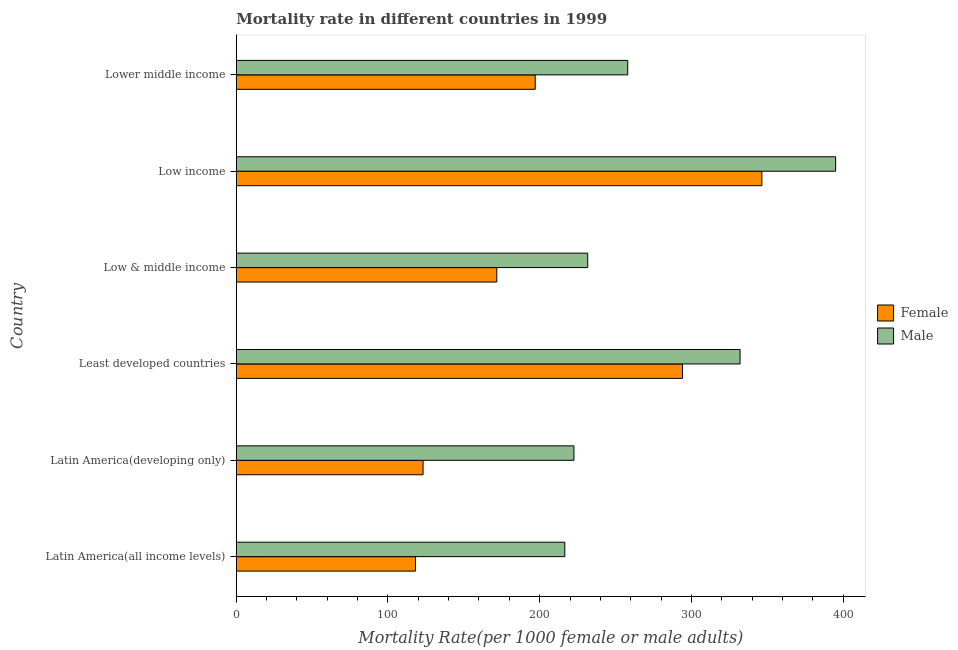How many different coloured bars are there?
Your answer should be compact. 2. Are the number of bars per tick equal to the number of legend labels?
Offer a terse response. Yes. Are the number of bars on each tick of the Y-axis equal?
Offer a terse response. Yes. How many bars are there on the 4th tick from the top?
Keep it short and to the point. 2. How many bars are there on the 6th tick from the bottom?
Your answer should be very brief. 2. What is the label of the 6th group of bars from the top?
Your response must be concise. Latin America(all income levels). In how many cases, is the number of bars for a given country not equal to the number of legend labels?
Make the answer very short. 0. What is the male mortality rate in Lower middle income?
Your response must be concise. 258.05. Across all countries, what is the maximum female mortality rate?
Keep it short and to the point. 346.49. Across all countries, what is the minimum male mortality rate?
Ensure brevity in your answer.  216.57. In which country was the male mortality rate maximum?
Offer a very short reply. Low income. In which country was the female mortality rate minimum?
Ensure brevity in your answer.  Latin America(all income levels). What is the total male mortality rate in the graph?
Offer a terse response. 1656.06. What is the difference between the male mortality rate in Latin America(all income levels) and that in Low & middle income?
Give a very brief answer. -15.1. What is the difference between the female mortality rate in Lower middle income and the male mortality rate in Latin America(all income levels)?
Give a very brief answer. -19.48. What is the average male mortality rate per country?
Provide a short and direct response. 276.01. What is the difference between the male mortality rate and female mortality rate in Least developed countries?
Offer a very short reply. 37.96. In how many countries, is the male mortality rate greater than 100 ?
Your answer should be very brief. 6. What is the ratio of the female mortality rate in Least developed countries to that in Lower middle income?
Your answer should be compact. 1.49. Is the male mortality rate in Least developed countries less than that in Low income?
Your response must be concise. Yes. Is the difference between the female mortality rate in Latin America(all income levels) and Lower middle income greater than the difference between the male mortality rate in Latin America(all income levels) and Lower middle income?
Provide a short and direct response. No. What is the difference between the highest and the second highest female mortality rate?
Ensure brevity in your answer.  52.34. What is the difference between the highest and the lowest female mortality rate?
Give a very brief answer. 228.35. How many bars are there?
Make the answer very short. 12. Are all the bars in the graph horizontal?
Ensure brevity in your answer.  Yes. Are the values on the major ticks of X-axis written in scientific E-notation?
Your response must be concise. No. Does the graph contain any zero values?
Keep it short and to the point. No. Does the graph contain grids?
Ensure brevity in your answer.  No. Where does the legend appear in the graph?
Make the answer very short. Center right. How are the legend labels stacked?
Your answer should be very brief. Vertical. What is the title of the graph?
Your response must be concise. Mortality rate in different countries in 1999. Does "International Tourists" appear as one of the legend labels in the graph?
Keep it short and to the point. No. What is the label or title of the X-axis?
Your answer should be very brief. Mortality Rate(per 1000 female or male adults). What is the Mortality Rate(per 1000 female or male adults) in Female in Latin America(all income levels)?
Your answer should be very brief. 118.14. What is the Mortality Rate(per 1000 female or male adults) in Male in Latin America(all income levels)?
Offer a terse response. 216.57. What is the Mortality Rate(per 1000 female or male adults) of Female in Latin America(developing only)?
Ensure brevity in your answer.  123.14. What is the Mortality Rate(per 1000 female or male adults) of Male in Latin America(developing only)?
Provide a short and direct response. 222.59. What is the Mortality Rate(per 1000 female or male adults) of Female in Least developed countries?
Your answer should be compact. 294.15. What is the Mortality Rate(per 1000 female or male adults) in Male in Least developed countries?
Make the answer very short. 332.1. What is the Mortality Rate(per 1000 female or male adults) of Female in Low & middle income?
Give a very brief answer. 171.74. What is the Mortality Rate(per 1000 female or male adults) of Male in Low & middle income?
Keep it short and to the point. 231.67. What is the Mortality Rate(per 1000 female or male adults) of Female in Low income?
Offer a terse response. 346.49. What is the Mortality Rate(per 1000 female or male adults) in Male in Low income?
Ensure brevity in your answer.  395.09. What is the Mortality Rate(per 1000 female or male adults) of Female in Lower middle income?
Give a very brief answer. 197.09. What is the Mortality Rate(per 1000 female or male adults) of Male in Lower middle income?
Ensure brevity in your answer.  258.05. Across all countries, what is the maximum Mortality Rate(per 1000 female or male adults) in Female?
Your response must be concise. 346.49. Across all countries, what is the maximum Mortality Rate(per 1000 female or male adults) in Male?
Your response must be concise. 395.09. Across all countries, what is the minimum Mortality Rate(per 1000 female or male adults) in Female?
Your answer should be compact. 118.14. Across all countries, what is the minimum Mortality Rate(per 1000 female or male adults) of Male?
Keep it short and to the point. 216.57. What is the total Mortality Rate(per 1000 female or male adults) in Female in the graph?
Your response must be concise. 1250.75. What is the total Mortality Rate(per 1000 female or male adults) in Male in the graph?
Give a very brief answer. 1656.06. What is the difference between the Mortality Rate(per 1000 female or male adults) of Female in Latin America(all income levels) and that in Latin America(developing only)?
Keep it short and to the point. -4.99. What is the difference between the Mortality Rate(per 1000 female or male adults) in Male in Latin America(all income levels) and that in Latin America(developing only)?
Offer a very short reply. -6.02. What is the difference between the Mortality Rate(per 1000 female or male adults) in Female in Latin America(all income levels) and that in Least developed countries?
Keep it short and to the point. -176. What is the difference between the Mortality Rate(per 1000 female or male adults) of Male in Latin America(all income levels) and that in Least developed countries?
Ensure brevity in your answer.  -115.54. What is the difference between the Mortality Rate(per 1000 female or male adults) in Female in Latin America(all income levels) and that in Low & middle income?
Make the answer very short. -53.6. What is the difference between the Mortality Rate(per 1000 female or male adults) of Male in Latin America(all income levels) and that in Low & middle income?
Provide a succinct answer. -15.1. What is the difference between the Mortality Rate(per 1000 female or male adults) of Female in Latin America(all income levels) and that in Low income?
Provide a short and direct response. -228.35. What is the difference between the Mortality Rate(per 1000 female or male adults) of Male in Latin America(all income levels) and that in Low income?
Your answer should be very brief. -178.53. What is the difference between the Mortality Rate(per 1000 female or male adults) in Female in Latin America(all income levels) and that in Lower middle income?
Ensure brevity in your answer.  -78.94. What is the difference between the Mortality Rate(per 1000 female or male adults) of Male in Latin America(all income levels) and that in Lower middle income?
Ensure brevity in your answer.  -41.48. What is the difference between the Mortality Rate(per 1000 female or male adults) in Female in Latin America(developing only) and that in Least developed countries?
Keep it short and to the point. -171.01. What is the difference between the Mortality Rate(per 1000 female or male adults) of Male in Latin America(developing only) and that in Least developed countries?
Give a very brief answer. -109.52. What is the difference between the Mortality Rate(per 1000 female or male adults) in Female in Latin America(developing only) and that in Low & middle income?
Your answer should be very brief. -48.6. What is the difference between the Mortality Rate(per 1000 female or male adults) of Male in Latin America(developing only) and that in Low & middle income?
Provide a succinct answer. -9.08. What is the difference between the Mortality Rate(per 1000 female or male adults) of Female in Latin America(developing only) and that in Low income?
Make the answer very short. -223.35. What is the difference between the Mortality Rate(per 1000 female or male adults) in Male in Latin America(developing only) and that in Low income?
Ensure brevity in your answer.  -172.51. What is the difference between the Mortality Rate(per 1000 female or male adults) of Female in Latin America(developing only) and that in Lower middle income?
Provide a succinct answer. -73.95. What is the difference between the Mortality Rate(per 1000 female or male adults) in Male in Latin America(developing only) and that in Lower middle income?
Ensure brevity in your answer.  -35.46. What is the difference between the Mortality Rate(per 1000 female or male adults) in Female in Least developed countries and that in Low & middle income?
Offer a very short reply. 122.4. What is the difference between the Mortality Rate(per 1000 female or male adults) in Male in Least developed countries and that in Low & middle income?
Your answer should be very brief. 100.44. What is the difference between the Mortality Rate(per 1000 female or male adults) in Female in Least developed countries and that in Low income?
Your response must be concise. -52.34. What is the difference between the Mortality Rate(per 1000 female or male adults) in Male in Least developed countries and that in Low income?
Offer a terse response. -62.99. What is the difference between the Mortality Rate(per 1000 female or male adults) of Female in Least developed countries and that in Lower middle income?
Give a very brief answer. 97.06. What is the difference between the Mortality Rate(per 1000 female or male adults) of Male in Least developed countries and that in Lower middle income?
Your answer should be compact. 74.06. What is the difference between the Mortality Rate(per 1000 female or male adults) of Female in Low & middle income and that in Low income?
Provide a short and direct response. -174.75. What is the difference between the Mortality Rate(per 1000 female or male adults) of Male in Low & middle income and that in Low income?
Your answer should be very brief. -163.42. What is the difference between the Mortality Rate(per 1000 female or male adults) of Female in Low & middle income and that in Lower middle income?
Keep it short and to the point. -25.35. What is the difference between the Mortality Rate(per 1000 female or male adults) of Male in Low & middle income and that in Lower middle income?
Your answer should be compact. -26.38. What is the difference between the Mortality Rate(per 1000 female or male adults) of Female in Low income and that in Lower middle income?
Your answer should be compact. 149.4. What is the difference between the Mortality Rate(per 1000 female or male adults) in Male in Low income and that in Lower middle income?
Your answer should be compact. 137.04. What is the difference between the Mortality Rate(per 1000 female or male adults) in Female in Latin America(all income levels) and the Mortality Rate(per 1000 female or male adults) in Male in Latin America(developing only)?
Provide a succinct answer. -104.44. What is the difference between the Mortality Rate(per 1000 female or male adults) in Female in Latin America(all income levels) and the Mortality Rate(per 1000 female or male adults) in Male in Least developed countries?
Make the answer very short. -213.96. What is the difference between the Mortality Rate(per 1000 female or male adults) of Female in Latin America(all income levels) and the Mortality Rate(per 1000 female or male adults) of Male in Low & middle income?
Offer a terse response. -113.52. What is the difference between the Mortality Rate(per 1000 female or male adults) in Female in Latin America(all income levels) and the Mortality Rate(per 1000 female or male adults) in Male in Low income?
Offer a very short reply. -276.95. What is the difference between the Mortality Rate(per 1000 female or male adults) of Female in Latin America(all income levels) and the Mortality Rate(per 1000 female or male adults) of Male in Lower middle income?
Provide a succinct answer. -139.9. What is the difference between the Mortality Rate(per 1000 female or male adults) in Female in Latin America(developing only) and the Mortality Rate(per 1000 female or male adults) in Male in Least developed countries?
Provide a succinct answer. -208.97. What is the difference between the Mortality Rate(per 1000 female or male adults) in Female in Latin America(developing only) and the Mortality Rate(per 1000 female or male adults) in Male in Low & middle income?
Offer a very short reply. -108.53. What is the difference between the Mortality Rate(per 1000 female or male adults) of Female in Latin America(developing only) and the Mortality Rate(per 1000 female or male adults) of Male in Low income?
Your answer should be very brief. -271.95. What is the difference between the Mortality Rate(per 1000 female or male adults) in Female in Latin America(developing only) and the Mortality Rate(per 1000 female or male adults) in Male in Lower middle income?
Keep it short and to the point. -134.91. What is the difference between the Mortality Rate(per 1000 female or male adults) in Female in Least developed countries and the Mortality Rate(per 1000 female or male adults) in Male in Low & middle income?
Offer a terse response. 62.48. What is the difference between the Mortality Rate(per 1000 female or male adults) in Female in Least developed countries and the Mortality Rate(per 1000 female or male adults) in Male in Low income?
Provide a succinct answer. -100.94. What is the difference between the Mortality Rate(per 1000 female or male adults) of Female in Least developed countries and the Mortality Rate(per 1000 female or male adults) of Male in Lower middle income?
Your response must be concise. 36.1. What is the difference between the Mortality Rate(per 1000 female or male adults) of Female in Low & middle income and the Mortality Rate(per 1000 female or male adults) of Male in Low income?
Offer a very short reply. -223.35. What is the difference between the Mortality Rate(per 1000 female or male adults) of Female in Low & middle income and the Mortality Rate(per 1000 female or male adults) of Male in Lower middle income?
Give a very brief answer. -86.3. What is the difference between the Mortality Rate(per 1000 female or male adults) in Female in Low income and the Mortality Rate(per 1000 female or male adults) in Male in Lower middle income?
Give a very brief answer. 88.44. What is the average Mortality Rate(per 1000 female or male adults) of Female per country?
Provide a short and direct response. 208.46. What is the average Mortality Rate(per 1000 female or male adults) in Male per country?
Give a very brief answer. 276.01. What is the difference between the Mortality Rate(per 1000 female or male adults) of Female and Mortality Rate(per 1000 female or male adults) of Male in Latin America(all income levels)?
Your answer should be very brief. -98.42. What is the difference between the Mortality Rate(per 1000 female or male adults) in Female and Mortality Rate(per 1000 female or male adults) in Male in Latin America(developing only)?
Give a very brief answer. -99.45. What is the difference between the Mortality Rate(per 1000 female or male adults) of Female and Mortality Rate(per 1000 female or male adults) of Male in Least developed countries?
Your answer should be very brief. -37.96. What is the difference between the Mortality Rate(per 1000 female or male adults) of Female and Mortality Rate(per 1000 female or male adults) of Male in Low & middle income?
Your answer should be compact. -59.92. What is the difference between the Mortality Rate(per 1000 female or male adults) of Female and Mortality Rate(per 1000 female or male adults) of Male in Low income?
Ensure brevity in your answer.  -48.6. What is the difference between the Mortality Rate(per 1000 female or male adults) of Female and Mortality Rate(per 1000 female or male adults) of Male in Lower middle income?
Your answer should be very brief. -60.96. What is the ratio of the Mortality Rate(per 1000 female or male adults) of Female in Latin America(all income levels) to that in Latin America(developing only)?
Give a very brief answer. 0.96. What is the ratio of the Mortality Rate(per 1000 female or male adults) in Male in Latin America(all income levels) to that in Latin America(developing only)?
Keep it short and to the point. 0.97. What is the ratio of the Mortality Rate(per 1000 female or male adults) of Female in Latin America(all income levels) to that in Least developed countries?
Your answer should be compact. 0.4. What is the ratio of the Mortality Rate(per 1000 female or male adults) in Male in Latin America(all income levels) to that in Least developed countries?
Provide a short and direct response. 0.65. What is the ratio of the Mortality Rate(per 1000 female or male adults) of Female in Latin America(all income levels) to that in Low & middle income?
Give a very brief answer. 0.69. What is the ratio of the Mortality Rate(per 1000 female or male adults) in Male in Latin America(all income levels) to that in Low & middle income?
Provide a short and direct response. 0.93. What is the ratio of the Mortality Rate(per 1000 female or male adults) of Female in Latin America(all income levels) to that in Low income?
Make the answer very short. 0.34. What is the ratio of the Mortality Rate(per 1000 female or male adults) in Male in Latin America(all income levels) to that in Low income?
Offer a terse response. 0.55. What is the ratio of the Mortality Rate(per 1000 female or male adults) in Female in Latin America(all income levels) to that in Lower middle income?
Your response must be concise. 0.6. What is the ratio of the Mortality Rate(per 1000 female or male adults) of Male in Latin America(all income levels) to that in Lower middle income?
Keep it short and to the point. 0.84. What is the ratio of the Mortality Rate(per 1000 female or male adults) in Female in Latin America(developing only) to that in Least developed countries?
Ensure brevity in your answer.  0.42. What is the ratio of the Mortality Rate(per 1000 female or male adults) of Male in Latin America(developing only) to that in Least developed countries?
Keep it short and to the point. 0.67. What is the ratio of the Mortality Rate(per 1000 female or male adults) in Female in Latin America(developing only) to that in Low & middle income?
Your answer should be very brief. 0.72. What is the ratio of the Mortality Rate(per 1000 female or male adults) of Male in Latin America(developing only) to that in Low & middle income?
Your answer should be very brief. 0.96. What is the ratio of the Mortality Rate(per 1000 female or male adults) in Female in Latin America(developing only) to that in Low income?
Offer a very short reply. 0.36. What is the ratio of the Mortality Rate(per 1000 female or male adults) of Male in Latin America(developing only) to that in Low income?
Give a very brief answer. 0.56. What is the ratio of the Mortality Rate(per 1000 female or male adults) of Female in Latin America(developing only) to that in Lower middle income?
Provide a succinct answer. 0.62. What is the ratio of the Mortality Rate(per 1000 female or male adults) of Male in Latin America(developing only) to that in Lower middle income?
Offer a very short reply. 0.86. What is the ratio of the Mortality Rate(per 1000 female or male adults) of Female in Least developed countries to that in Low & middle income?
Make the answer very short. 1.71. What is the ratio of the Mortality Rate(per 1000 female or male adults) of Male in Least developed countries to that in Low & middle income?
Keep it short and to the point. 1.43. What is the ratio of the Mortality Rate(per 1000 female or male adults) of Female in Least developed countries to that in Low income?
Offer a very short reply. 0.85. What is the ratio of the Mortality Rate(per 1000 female or male adults) of Male in Least developed countries to that in Low income?
Provide a short and direct response. 0.84. What is the ratio of the Mortality Rate(per 1000 female or male adults) in Female in Least developed countries to that in Lower middle income?
Make the answer very short. 1.49. What is the ratio of the Mortality Rate(per 1000 female or male adults) in Male in Least developed countries to that in Lower middle income?
Ensure brevity in your answer.  1.29. What is the ratio of the Mortality Rate(per 1000 female or male adults) of Female in Low & middle income to that in Low income?
Make the answer very short. 0.5. What is the ratio of the Mortality Rate(per 1000 female or male adults) in Male in Low & middle income to that in Low income?
Your answer should be very brief. 0.59. What is the ratio of the Mortality Rate(per 1000 female or male adults) of Female in Low & middle income to that in Lower middle income?
Your response must be concise. 0.87. What is the ratio of the Mortality Rate(per 1000 female or male adults) in Male in Low & middle income to that in Lower middle income?
Ensure brevity in your answer.  0.9. What is the ratio of the Mortality Rate(per 1000 female or male adults) of Female in Low income to that in Lower middle income?
Keep it short and to the point. 1.76. What is the ratio of the Mortality Rate(per 1000 female or male adults) of Male in Low income to that in Lower middle income?
Your response must be concise. 1.53. What is the difference between the highest and the second highest Mortality Rate(per 1000 female or male adults) of Female?
Your response must be concise. 52.34. What is the difference between the highest and the second highest Mortality Rate(per 1000 female or male adults) in Male?
Your response must be concise. 62.99. What is the difference between the highest and the lowest Mortality Rate(per 1000 female or male adults) of Female?
Your answer should be very brief. 228.35. What is the difference between the highest and the lowest Mortality Rate(per 1000 female or male adults) of Male?
Keep it short and to the point. 178.53. 